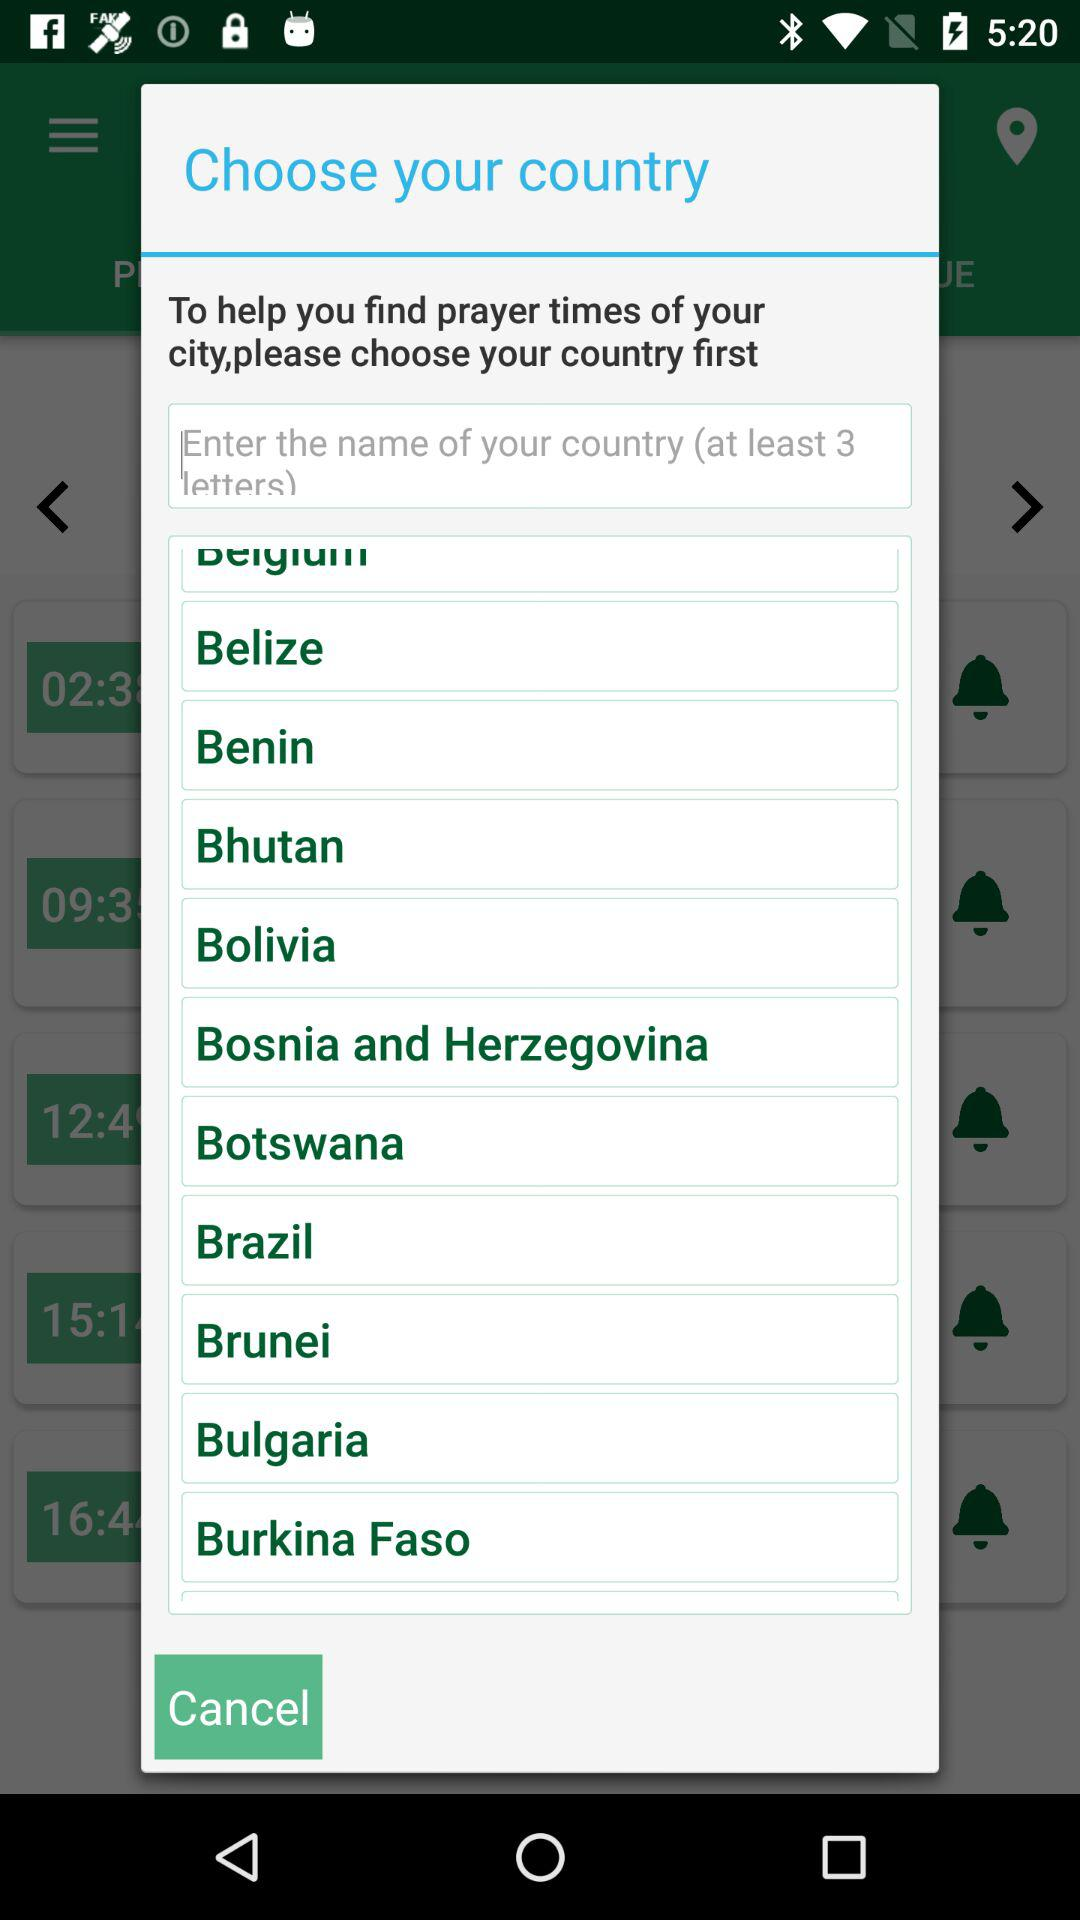What are all the available countries in the list? The list of the available countries "Belize", "Benin", "Bhutan", "Bolivia", "Bosnia and Herzegovina", "Botswana", "Brazil", "Brunei", "Bulgaria", and "Burkina Faso". 